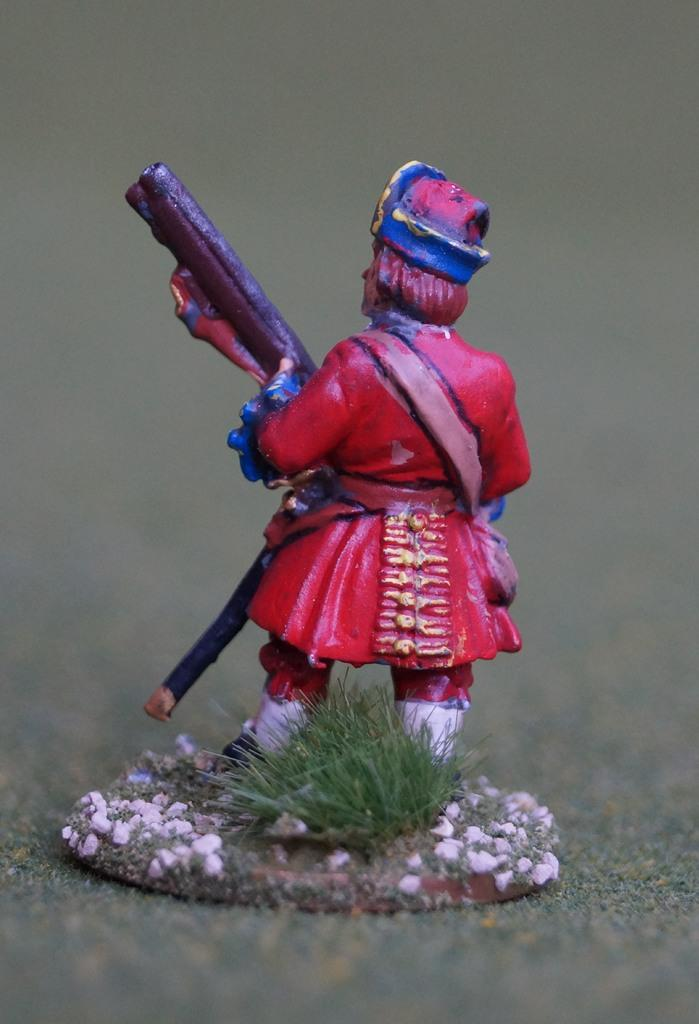What is the main subject of the image? There is a small sculpture of a person in the image. Where is the sculpture located in relation to the grass? The sculpture is standing beside the grass. What other elements can be seen in the image? Flower plants are present in the image. What type of thunder can be heard in the image? There is no sound, including thunder, present in the image. Is there a maid attending to the flower plants in the image? There is no maid present in the image; it only features a small sculpture of a person and flower plants. 